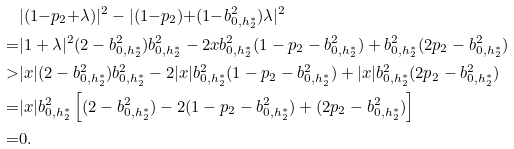Convert formula to latex. <formula><loc_0><loc_0><loc_500><loc_500>& | ( 1 { - } p _ { 2 } { + } \lambda ) | ^ { 2 } - | ( 1 { - } p _ { 2 } ) { + } ( 1 { - } b _ { 0 , h ^ { * } _ { 2 } } ^ { 2 } ) \lambda | ^ { 2 } \\ = & | 1 + \lambda | ^ { 2 } ( 2 - b _ { 0 , h ^ { * } _ { 2 } } ^ { 2 } ) b _ { 0 , h ^ { * } _ { 2 } } ^ { 2 } - 2 x b _ { 0 , h ^ { * } _ { 2 } } ^ { 2 } ( 1 - p _ { 2 } - b _ { 0 , h ^ { * } _ { 2 } } ^ { 2 } ) + b _ { 0 , h ^ { * } _ { 2 } } ^ { 2 } ( 2 p _ { 2 } - b _ { 0 , h ^ { * } _ { 2 } } ^ { 2 } ) \\ > & | x | ( 2 - b _ { 0 , h ^ { * } _ { 2 } } ^ { 2 } ) b _ { 0 , h ^ { * } _ { 2 } } ^ { 2 } - 2 | x | b _ { 0 , h ^ { * } _ { 2 } } ^ { 2 } ( 1 - p _ { 2 } - b _ { 0 , h ^ { * } _ { 2 } } ^ { 2 } ) + | x | b _ { 0 , h ^ { * } _ { 2 } } ^ { 2 } ( 2 p _ { 2 } - b _ { 0 , h ^ { * } _ { 2 } } ^ { 2 } ) \\ = & | x | b _ { 0 , h ^ { * } _ { 2 } } ^ { 2 } \left [ ( 2 - b _ { 0 , h ^ { * } _ { 2 } } ^ { 2 } ) - 2 ( 1 - p _ { 2 } - b _ { 0 , h ^ { * } _ { 2 } } ^ { 2 } ) + ( 2 p _ { 2 } - b _ { 0 , h ^ { * } _ { 2 } } ^ { 2 } ) \right ] \\ = & 0 .</formula> 